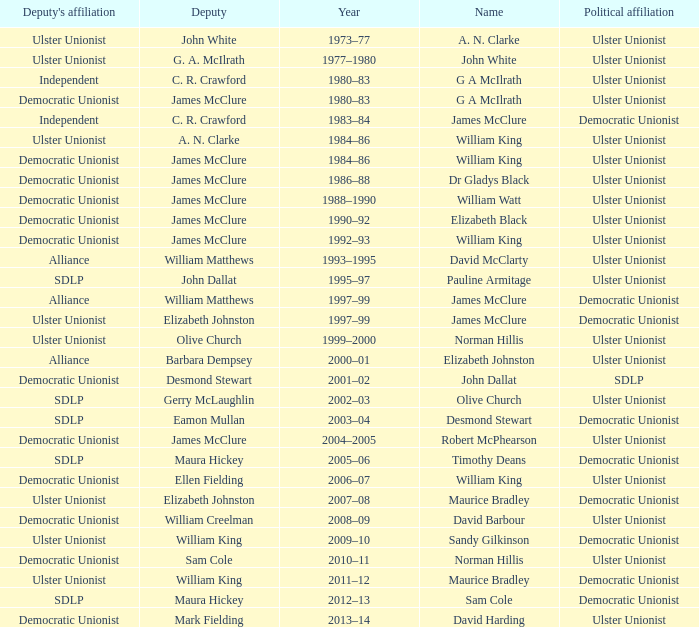What is the name of the Deputy when the Name was elizabeth black? James McClure. 